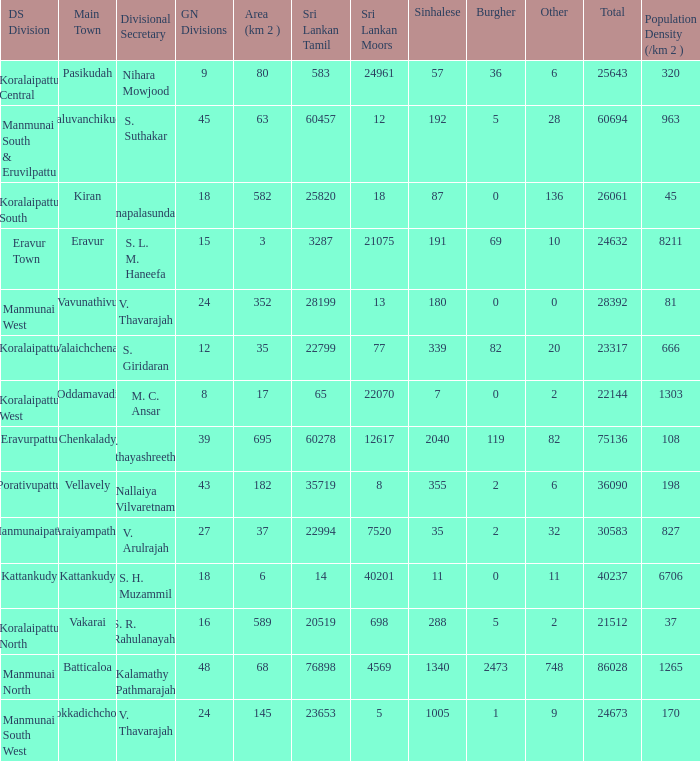What is the name of the DS division where the divisional secretary is S. H. Muzammil? Kattankudy. 